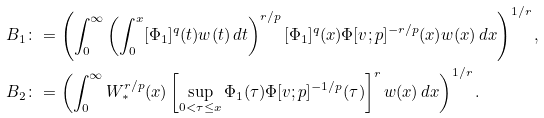<formula> <loc_0><loc_0><loc_500><loc_500>B _ { 1 } \colon & = \left ( \int _ { 0 } ^ { \infty } \left ( \int _ { 0 } ^ { x } [ \Phi _ { 1 } ] ^ { q } ( t ) w ( t ) \, d t \right ) ^ { r / p } [ \Phi _ { 1 } ] ^ { q } ( x ) \Phi [ v ; p ] ^ { - r / p } ( x ) w ( x ) \, d x \right ) ^ { 1 / r } , \\ B _ { 2 } \colon & = \left ( \int _ { 0 } ^ { \infty } W _ { * } ^ { r / p } ( x ) \left [ \sup _ { 0 < \tau \leq x } \Phi _ { 1 } ( \tau ) \Phi [ v ; p ] ^ { - 1 / p } ( \tau ) \right ] ^ { r } w ( x ) \, d x \right ) ^ { 1 / r } .</formula> 